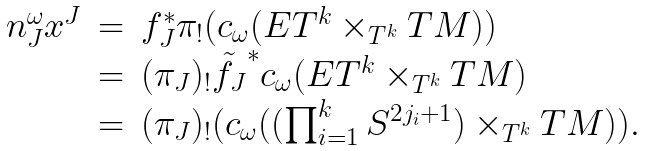<formula> <loc_0><loc_0><loc_500><loc_500>\begin{array} { c c l } n _ { J } ^ { \omega } x ^ { J } & = & f _ { J } ^ { * } \pi _ { ! } ( c _ { \omega } ( E T ^ { k } \times _ { T ^ { k } } T M ) ) \\ & = & ( \pi _ { J } ) _ { ! } \tilde { f _ { J } } ^ { * } c _ { \omega } ( E T ^ { k } \times _ { T ^ { k } } T M ) \\ & = & ( \pi _ { J } ) _ { ! } ( c _ { \omega } ( ( \prod _ { i = 1 } ^ { k } S ^ { 2 j _ { i } + 1 } ) \times _ { T ^ { k } } T M ) ) . \end{array}</formula> 